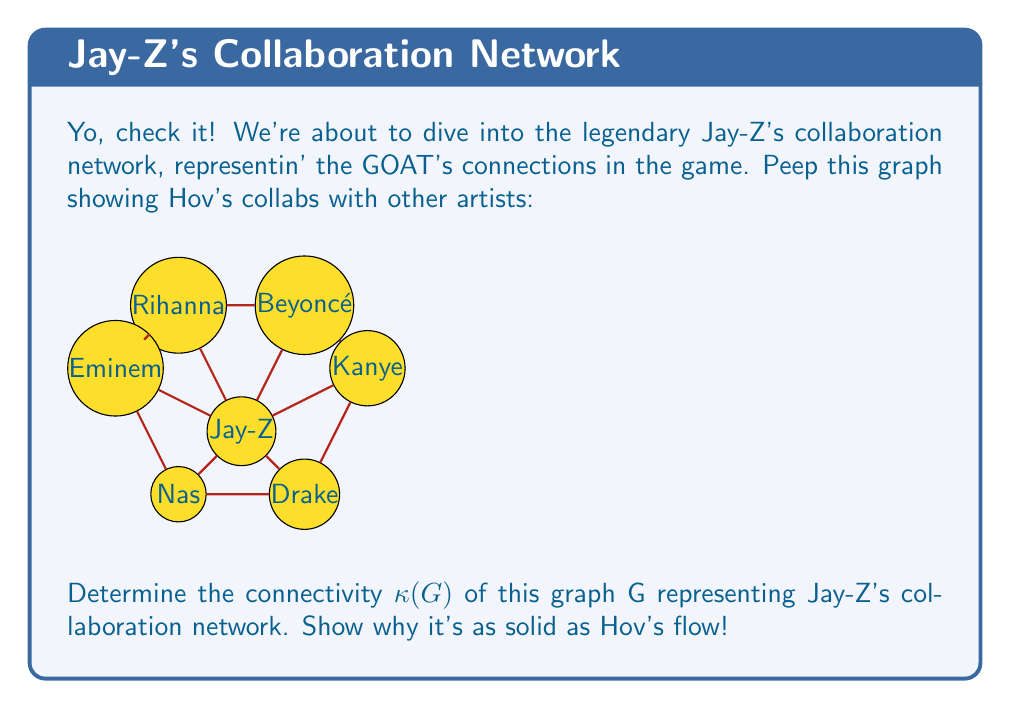Can you solve this math problem? Aight, let's break this down like Jay breaks down beats:

1) First, we gotta understand what connectivity means. The connectivity $\kappa(G)$ of a graph G is the minimum number of vertices you gotta remove to disconnect the graph or reduce it to a single vertex.

2) Now, let's look at our man Jay-Z's position in this graph. He's connected to all other vertices, makin' him the center of this collaboration empire. That's why he's the GOAT!

3) To find $\kappa(G)$, we need to consider the minimum cut set. That's the smallest set of vertices that, if removed, would disconnect the graph.

4) If we remove Jay-Z (which hurts to even think about), the graph gets disconnected into individual vertices. But that's just one vertex removal.

5) If we try to disconnect the graph by removing any other combination of vertices that doesn't include Jay-Z, we'd need to remove at least 2 vertices to break the cycle formed by the other artists.

6) So, the minimum number of vertices we need to remove to disconnect the graph is 1, and that's by removing Jay-Z himself.

7) Therefore, the connectivity of this graph, $\kappa(G)$, is 1.

This low connectivity might seem surprising for the king, but it actually shows how central Jay-Z is to this network. He's the crucial connection point, just like he's the crucial figure in hip-hop. Without him, the whole network falls apart, just like the rap game would without Hov!
Answer: $\kappa(G) = 1$ 